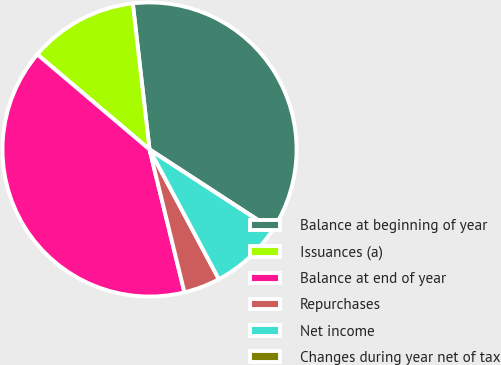<chart> <loc_0><loc_0><loc_500><loc_500><pie_chart><fcel>Balance at beginning of year<fcel>Issuances (a)<fcel>Balance at end of year<fcel>Repurchases<fcel>Net income<fcel>Changes during year net of tax<nl><fcel>36.0%<fcel>12.0%<fcel>40.0%<fcel>4.0%<fcel>8.0%<fcel>0.0%<nl></chart> 